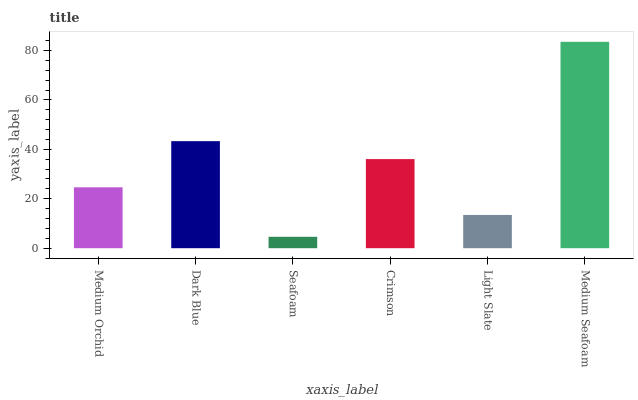Is Seafoam the minimum?
Answer yes or no. Yes. Is Medium Seafoam the maximum?
Answer yes or no. Yes. Is Dark Blue the minimum?
Answer yes or no. No. Is Dark Blue the maximum?
Answer yes or no. No. Is Dark Blue greater than Medium Orchid?
Answer yes or no. Yes. Is Medium Orchid less than Dark Blue?
Answer yes or no. Yes. Is Medium Orchid greater than Dark Blue?
Answer yes or no. No. Is Dark Blue less than Medium Orchid?
Answer yes or no. No. Is Crimson the high median?
Answer yes or no. Yes. Is Medium Orchid the low median?
Answer yes or no. Yes. Is Medium Orchid the high median?
Answer yes or no. No. Is Light Slate the low median?
Answer yes or no. No. 